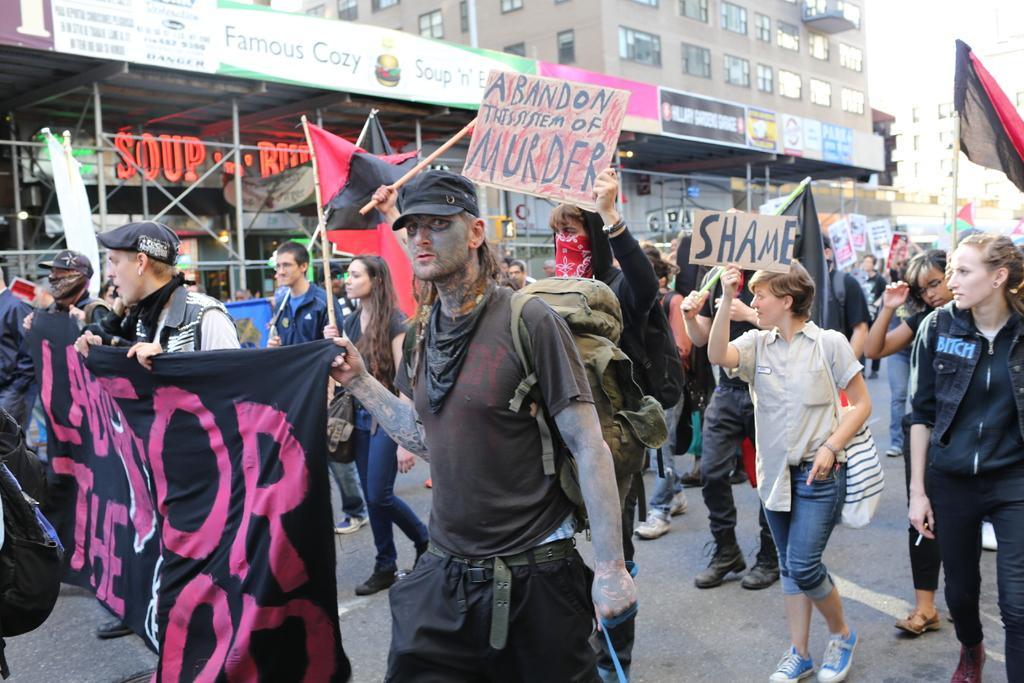Please provide a concise description of this image. In this image there are group of people who are holding some placards and some of them are holding banners, and some of them are holding flags and walking. In the background there are buildings, boards. On the boards there is text, poles and some other objects. At the bottom there is a walkway. 